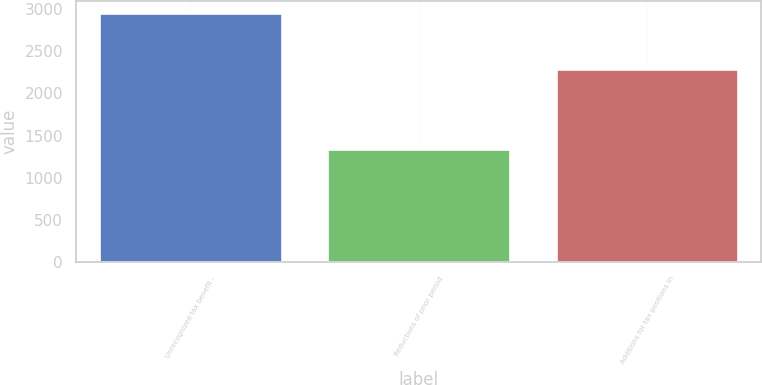Convert chart to OTSL. <chart><loc_0><loc_0><loc_500><loc_500><bar_chart><fcel>Unrecognized tax benefit -<fcel>Reductions of prior period<fcel>Additions for tax positions in<nl><fcel>2951<fcel>1336<fcel>2292.5<nl></chart> 